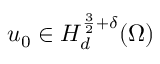<formula> <loc_0><loc_0><loc_500><loc_500>u _ { 0 } \in H _ { d } ^ { \frac { 3 } { 2 } + \delta } ( \Omega )</formula> 